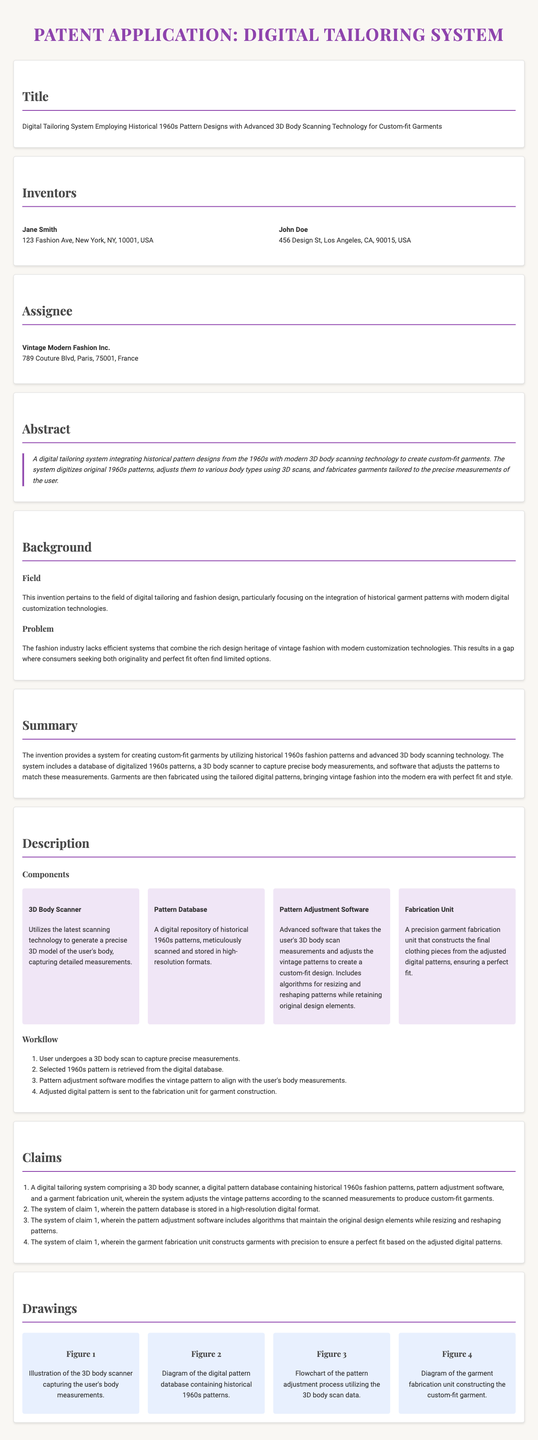What is the title of the patent application? The title is stated at the beginning of the document, summarizing the purpose of the new system.
Answer: Digital Tailoring System Employing Historical 1960s Pattern Designs with Advanced 3D Body Scanning Technology for Custom-fit Garments Who are the inventors? The names of the inventors are listed in the "Inventors" section of the document.
Answer: Jane Smith, John Doe What company is the assignee? The company listed under the "Assignee" section indicates the ownership of the patent application.
Answer: Vintage Modern Fashion Inc What is the primary industry focus of the invention? The "Background" section specifies the particular field this invention relates to.
Answer: Digital tailoring and fashion design How many components does the digital tailoring system include? In the "Components" section, several elements of the system are mentioned, indicating the number of unique parts.
Answer: Four What is the purpose of the 3D body scanner in this system? The description of the 3D Body Scanner provides insights into its function within the digital tailoring system.
Answer: Generate a precise 3D model of the user's body Which decade's fashion patterns does the system utilize? The abstract section clearly indicates the historical source of the patterns used in the tailoring system.
Answer: 1960s What is the first step in the workflow for creating custom-fit garments? The "Workflow" section outlines the sequential steps in the garment creation process, specifying the initial action.
Answer: User undergoes a 3D body scan How does the pattern adjustment software assist in the tailoring process? The "Pattern Adjustment Software" component description explains its role in modifying vintage patterns.
Answer: Adjusts the vintage patterns to create a custom-fit design 